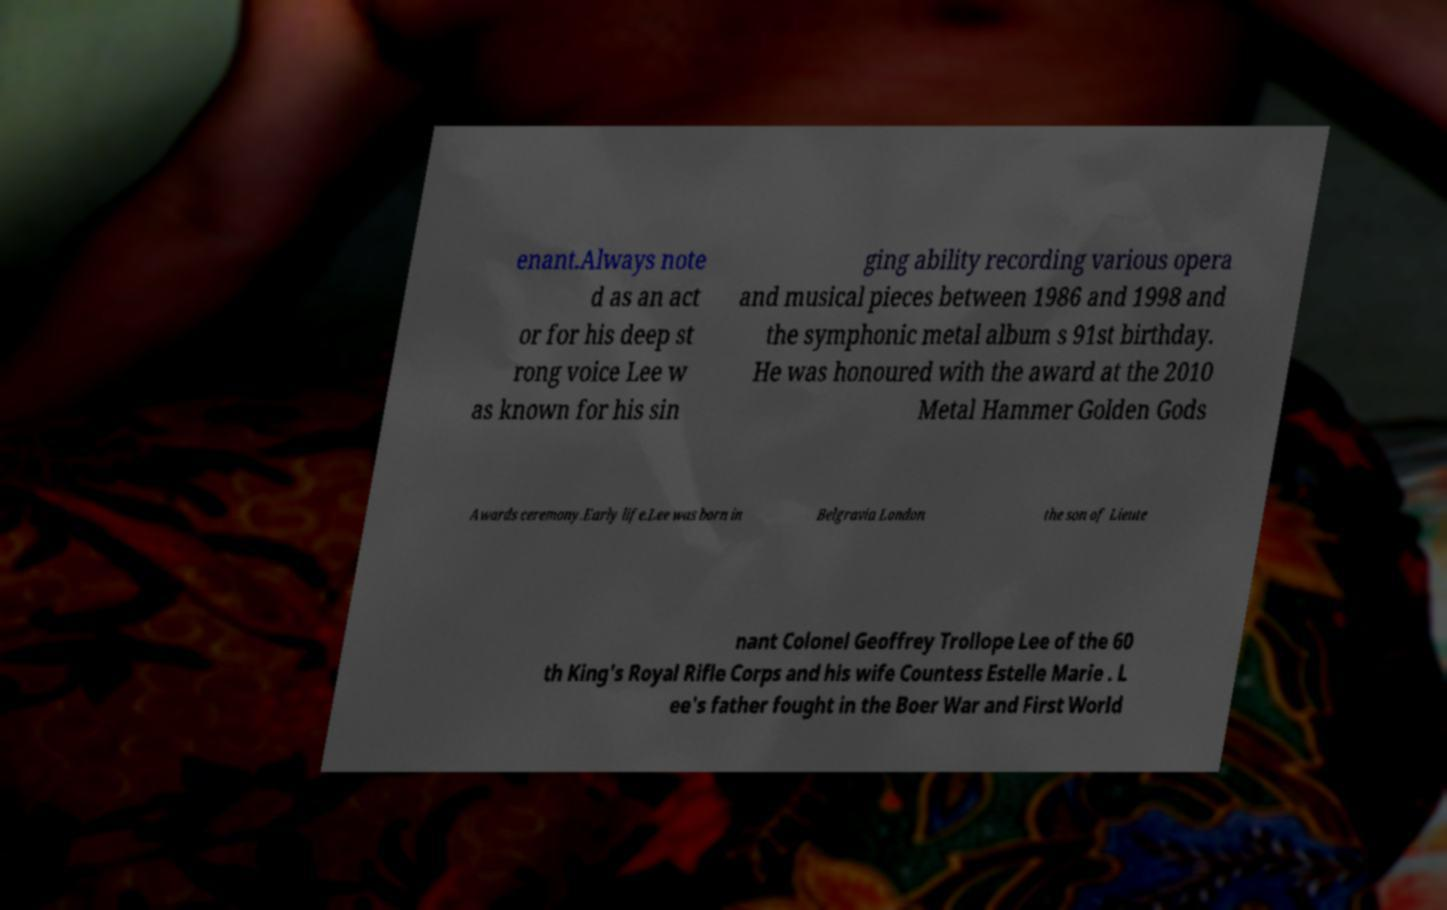Can you read and provide the text displayed in the image?This photo seems to have some interesting text. Can you extract and type it out for me? enant.Always note d as an act or for his deep st rong voice Lee w as known for his sin ging ability recording various opera and musical pieces between 1986 and 1998 and the symphonic metal album s 91st birthday. He was honoured with the award at the 2010 Metal Hammer Golden Gods Awards ceremony.Early life.Lee was born in Belgravia London the son of Lieute nant Colonel Geoffrey Trollope Lee of the 60 th King's Royal Rifle Corps and his wife Countess Estelle Marie . L ee's father fought in the Boer War and First World 